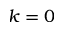<formula> <loc_0><loc_0><loc_500><loc_500>k = 0</formula> 